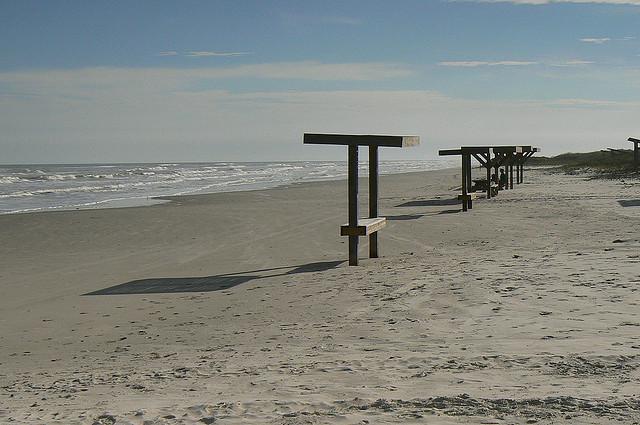Is the water calm?
Write a very short answer. No. How many boats are in the picture?
Give a very brief answer. 0. What is parked by the bench?
Be succinct. Nothing. Where is this located?
Short answer required. Beach. What color is the sky?
Keep it brief. Blue. How many benches are present?
Concise answer only. 4. Can you see grass?
Quick response, please. No. Where is the bench facing?
Short answer required. Ocean. What season is this?
Quick response, please. Summer. How many train tracks are in this photo?
Concise answer only. 0. Is that a chair on the beach?
Answer briefly. No. Is the sand on this beach white?
Write a very short answer. No. Is it a windy day?
Be succinct. No. What is flying in the sky?
Give a very brief answer. Clouds. 